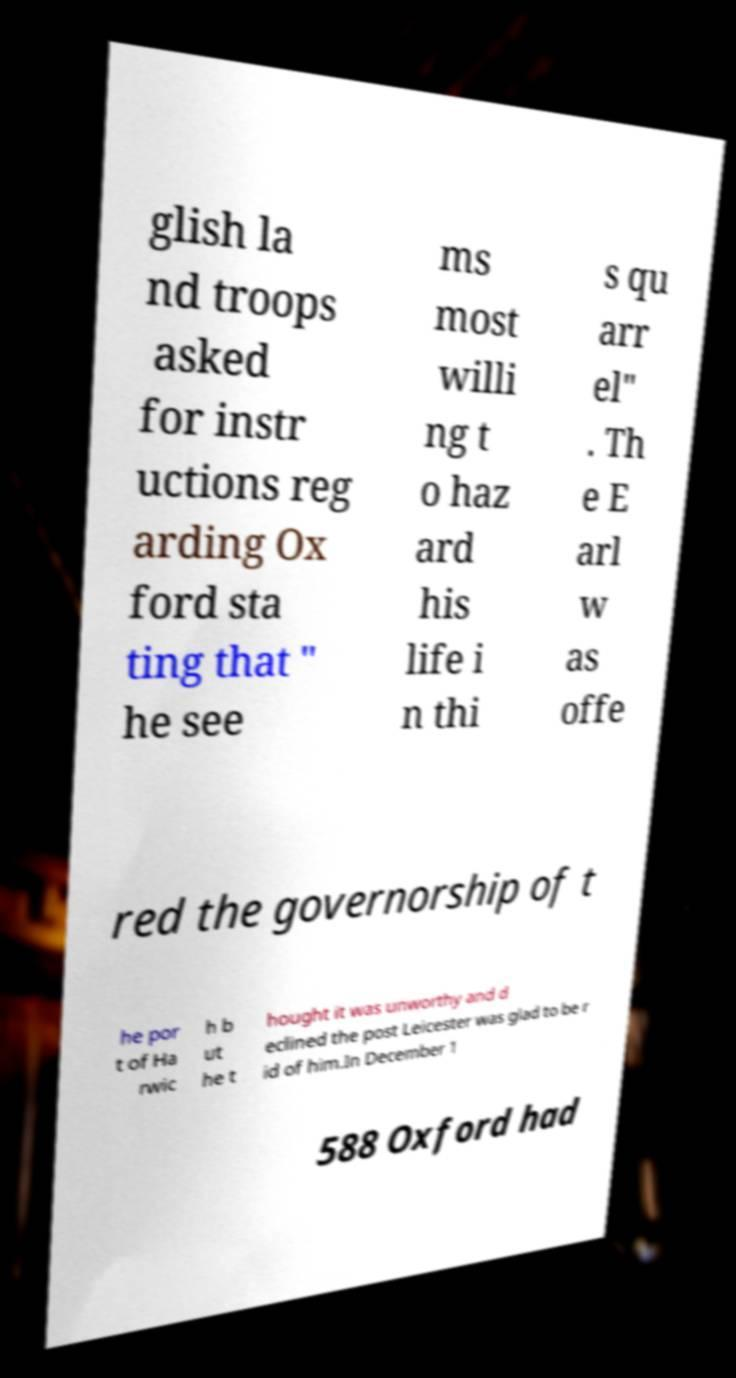Please identify and transcribe the text found in this image. glish la nd troops asked for instr uctions reg arding Ox ford sta ting that " he see ms most willi ng t o haz ard his life i n thi s qu arr el" . Th e E arl w as offe red the governorship of t he por t of Ha rwic h b ut he t hought it was unworthy and d eclined the post Leicester was glad to be r id of him.In December 1 588 Oxford had 